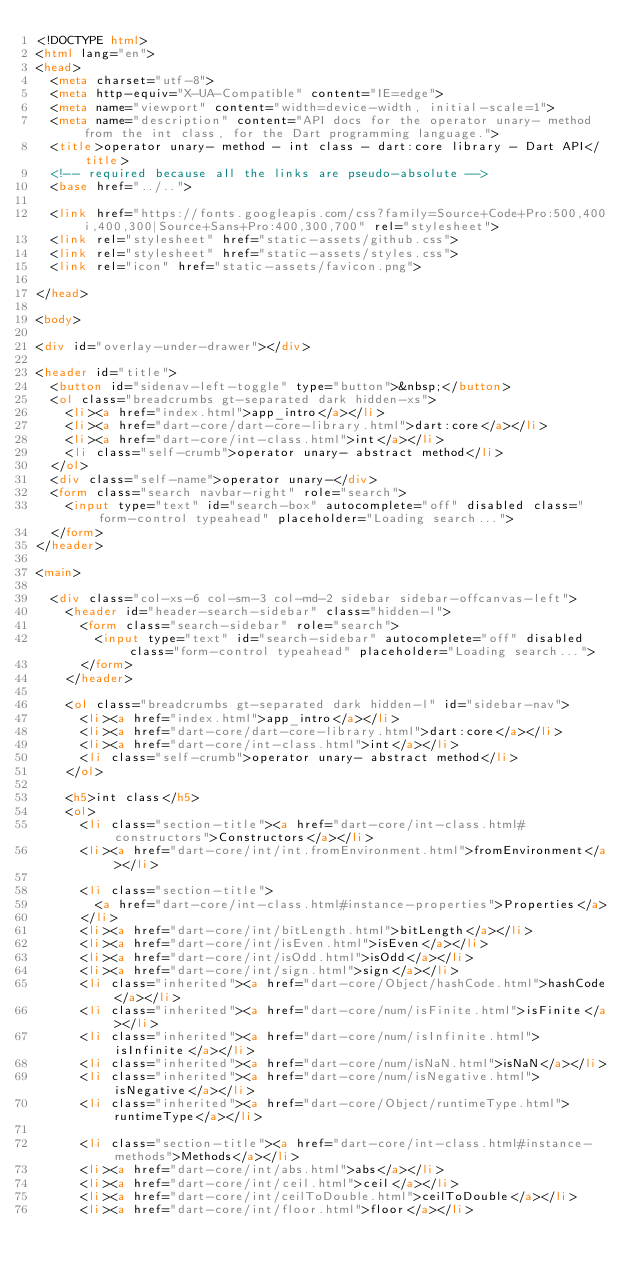Convert code to text. <code><loc_0><loc_0><loc_500><loc_500><_HTML_><!DOCTYPE html>
<html lang="en">
<head>
  <meta charset="utf-8">
  <meta http-equiv="X-UA-Compatible" content="IE=edge">
  <meta name="viewport" content="width=device-width, initial-scale=1">
  <meta name="description" content="API docs for the operator unary- method from the int class, for the Dart programming language.">
  <title>operator unary- method - int class - dart:core library - Dart API</title>
  <!-- required because all the links are pseudo-absolute -->
  <base href="../..">

  <link href="https://fonts.googleapis.com/css?family=Source+Code+Pro:500,400i,400,300|Source+Sans+Pro:400,300,700" rel="stylesheet">
  <link rel="stylesheet" href="static-assets/github.css">
  <link rel="stylesheet" href="static-assets/styles.css">
  <link rel="icon" href="static-assets/favicon.png">
  
</head>

<body>

<div id="overlay-under-drawer"></div>

<header id="title">
  <button id="sidenav-left-toggle" type="button">&nbsp;</button>
  <ol class="breadcrumbs gt-separated dark hidden-xs">
    <li><a href="index.html">app_intro</a></li>
    <li><a href="dart-core/dart-core-library.html">dart:core</a></li>
    <li><a href="dart-core/int-class.html">int</a></li>
    <li class="self-crumb">operator unary- abstract method</li>
  </ol>
  <div class="self-name">operator unary-</div>
  <form class="search navbar-right" role="search">
    <input type="text" id="search-box" autocomplete="off" disabled class="form-control typeahead" placeholder="Loading search...">
  </form>
</header>

<main>

  <div class="col-xs-6 col-sm-3 col-md-2 sidebar sidebar-offcanvas-left">
    <header id="header-search-sidebar" class="hidden-l">
      <form class="search-sidebar" role="search">
        <input type="text" id="search-sidebar" autocomplete="off" disabled class="form-control typeahead" placeholder="Loading search...">
      </form>
    </header>
    
    <ol class="breadcrumbs gt-separated dark hidden-l" id="sidebar-nav">
      <li><a href="index.html">app_intro</a></li>
      <li><a href="dart-core/dart-core-library.html">dart:core</a></li>
      <li><a href="dart-core/int-class.html">int</a></li>
      <li class="self-crumb">operator unary- abstract method</li>
    </ol>
    
    <h5>int class</h5>
    <ol>
      <li class="section-title"><a href="dart-core/int-class.html#constructors">Constructors</a></li>
      <li><a href="dart-core/int/int.fromEnvironment.html">fromEnvironment</a></li>
    
      <li class="section-title">
        <a href="dart-core/int-class.html#instance-properties">Properties</a>
      </li>
      <li><a href="dart-core/int/bitLength.html">bitLength</a></li>
      <li><a href="dart-core/int/isEven.html">isEven</a></li>
      <li><a href="dart-core/int/isOdd.html">isOdd</a></li>
      <li><a href="dart-core/int/sign.html">sign</a></li>
      <li class="inherited"><a href="dart-core/Object/hashCode.html">hashCode</a></li>
      <li class="inherited"><a href="dart-core/num/isFinite.html">isFinite</a></li>
      <li class="inherited"><a href="dart-core/num/isInfinite.html">isInfinite</a></li>
      <li class="inherited"><a href="dart-core/num/isNaN.html">isNaN</a></li>
      <li class="inherited"><a href="dart-core/num/isNegative.html">isNegative</a></li>
      <li class="inherited"><a href="dart-core/Object/runtimeType.html">runtimeType</a></li>
    
      <li class="section-title"><a href="dart-core/int-class.html#instance-methods">Methods</a></li>
      <li><a href="dart-core/int/abs.html">abs</a></li>
      <li><a href="dart-core/int/ceil.html">ceil</a></li>
      <li><a href="dart-core/int/ceilToDouble.html">ceilToDouble</a></li>
      <li><a href="dart-core/int/floor.html">floor</a></li></code> 